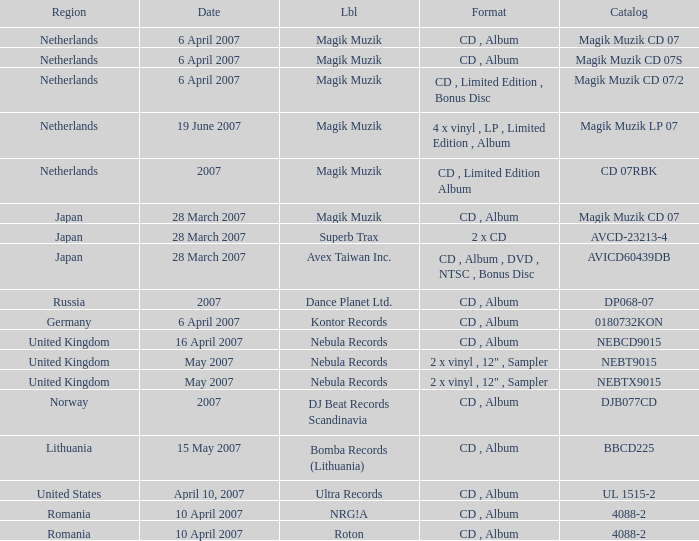From which region is the album with release date of 19 June 2007? Netherlands. 